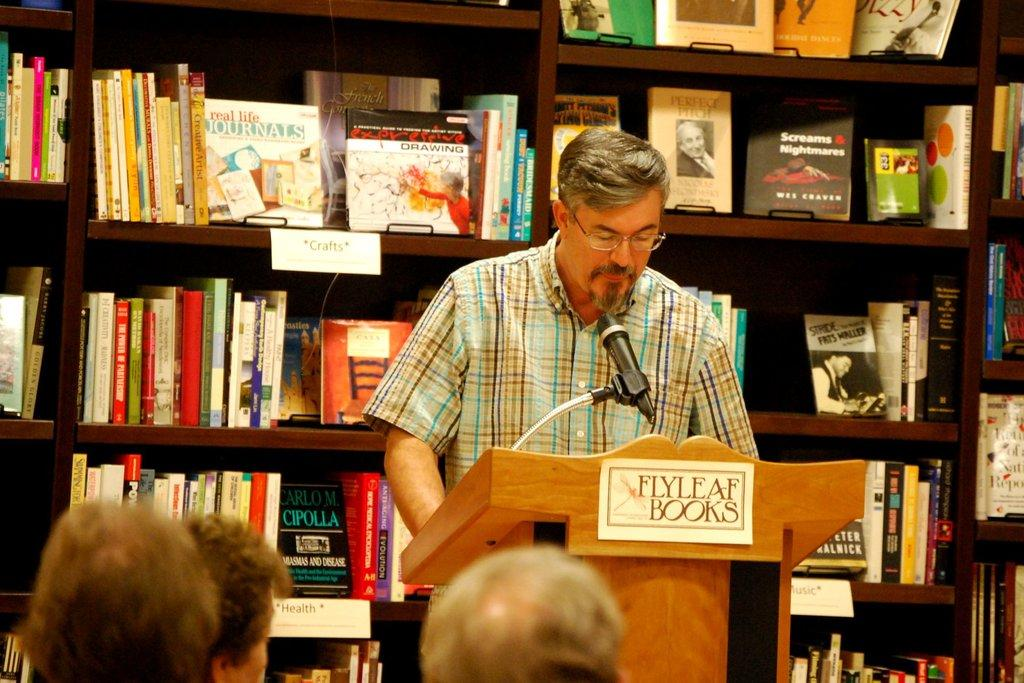<image>
Present a compact description of the photo's key features. Man giving a presentation behind a podium that says Fly Leaf Books. 